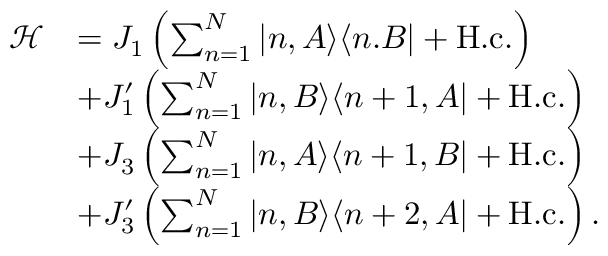<formula> <loc_0><loc_0><loc_500><loc_500>\begin{array} { r l } { \mathcal { H } } & { = J _ { 1 } \left ( \sum _ { n = 1 } ^ { N } | n , A \rangle \langle n . B | + H . c . \right ) } \\ & { + J _ { 1 } ^ { \prime } \left ( \sum _ { n = 1 } ^ { N } | n , B \rangle \langle n + 1 , A | + H . c . \right ) } \\ & { + J _ { 3 } \left ( \sum _ { n = 1 } ^ { N } | n , A \rangle \langle n + 1 , B | + H . c . \right ) } \\ & { + J _ { 3 } ^ { \prime } \left ( \sum _ { n = 1 } ^ { N } | n , B \rangle \langle n + 2 , A | + H . c . \right ) . } \end{array}</formula> 